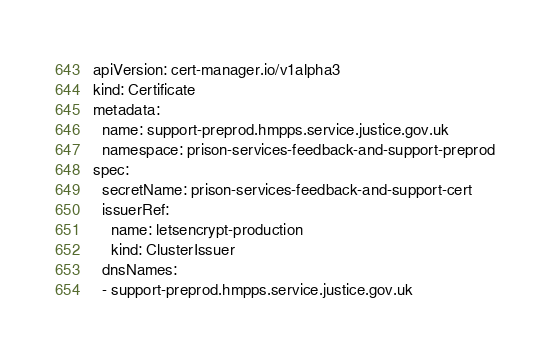Convert code to text. <code><loc_0><loc_0><loc_500><loc_500><_YAML_>apiVersion: cert-manager.io/v1alpha3
kind: Certificate
metadata:
  name: support-preprod.hmpps.service.justice.gov.uk
  namespace: prison-services-feedback-and-support-preprod
spec:
  secretName: prison-services-feedback-and-support-cert
  issuerRef:
    name: letsencrypt-production
    kind: ClusterIssuer
  dnsNames:
  - support-preprod.hmpps.service.justice.gov.uk</code> 